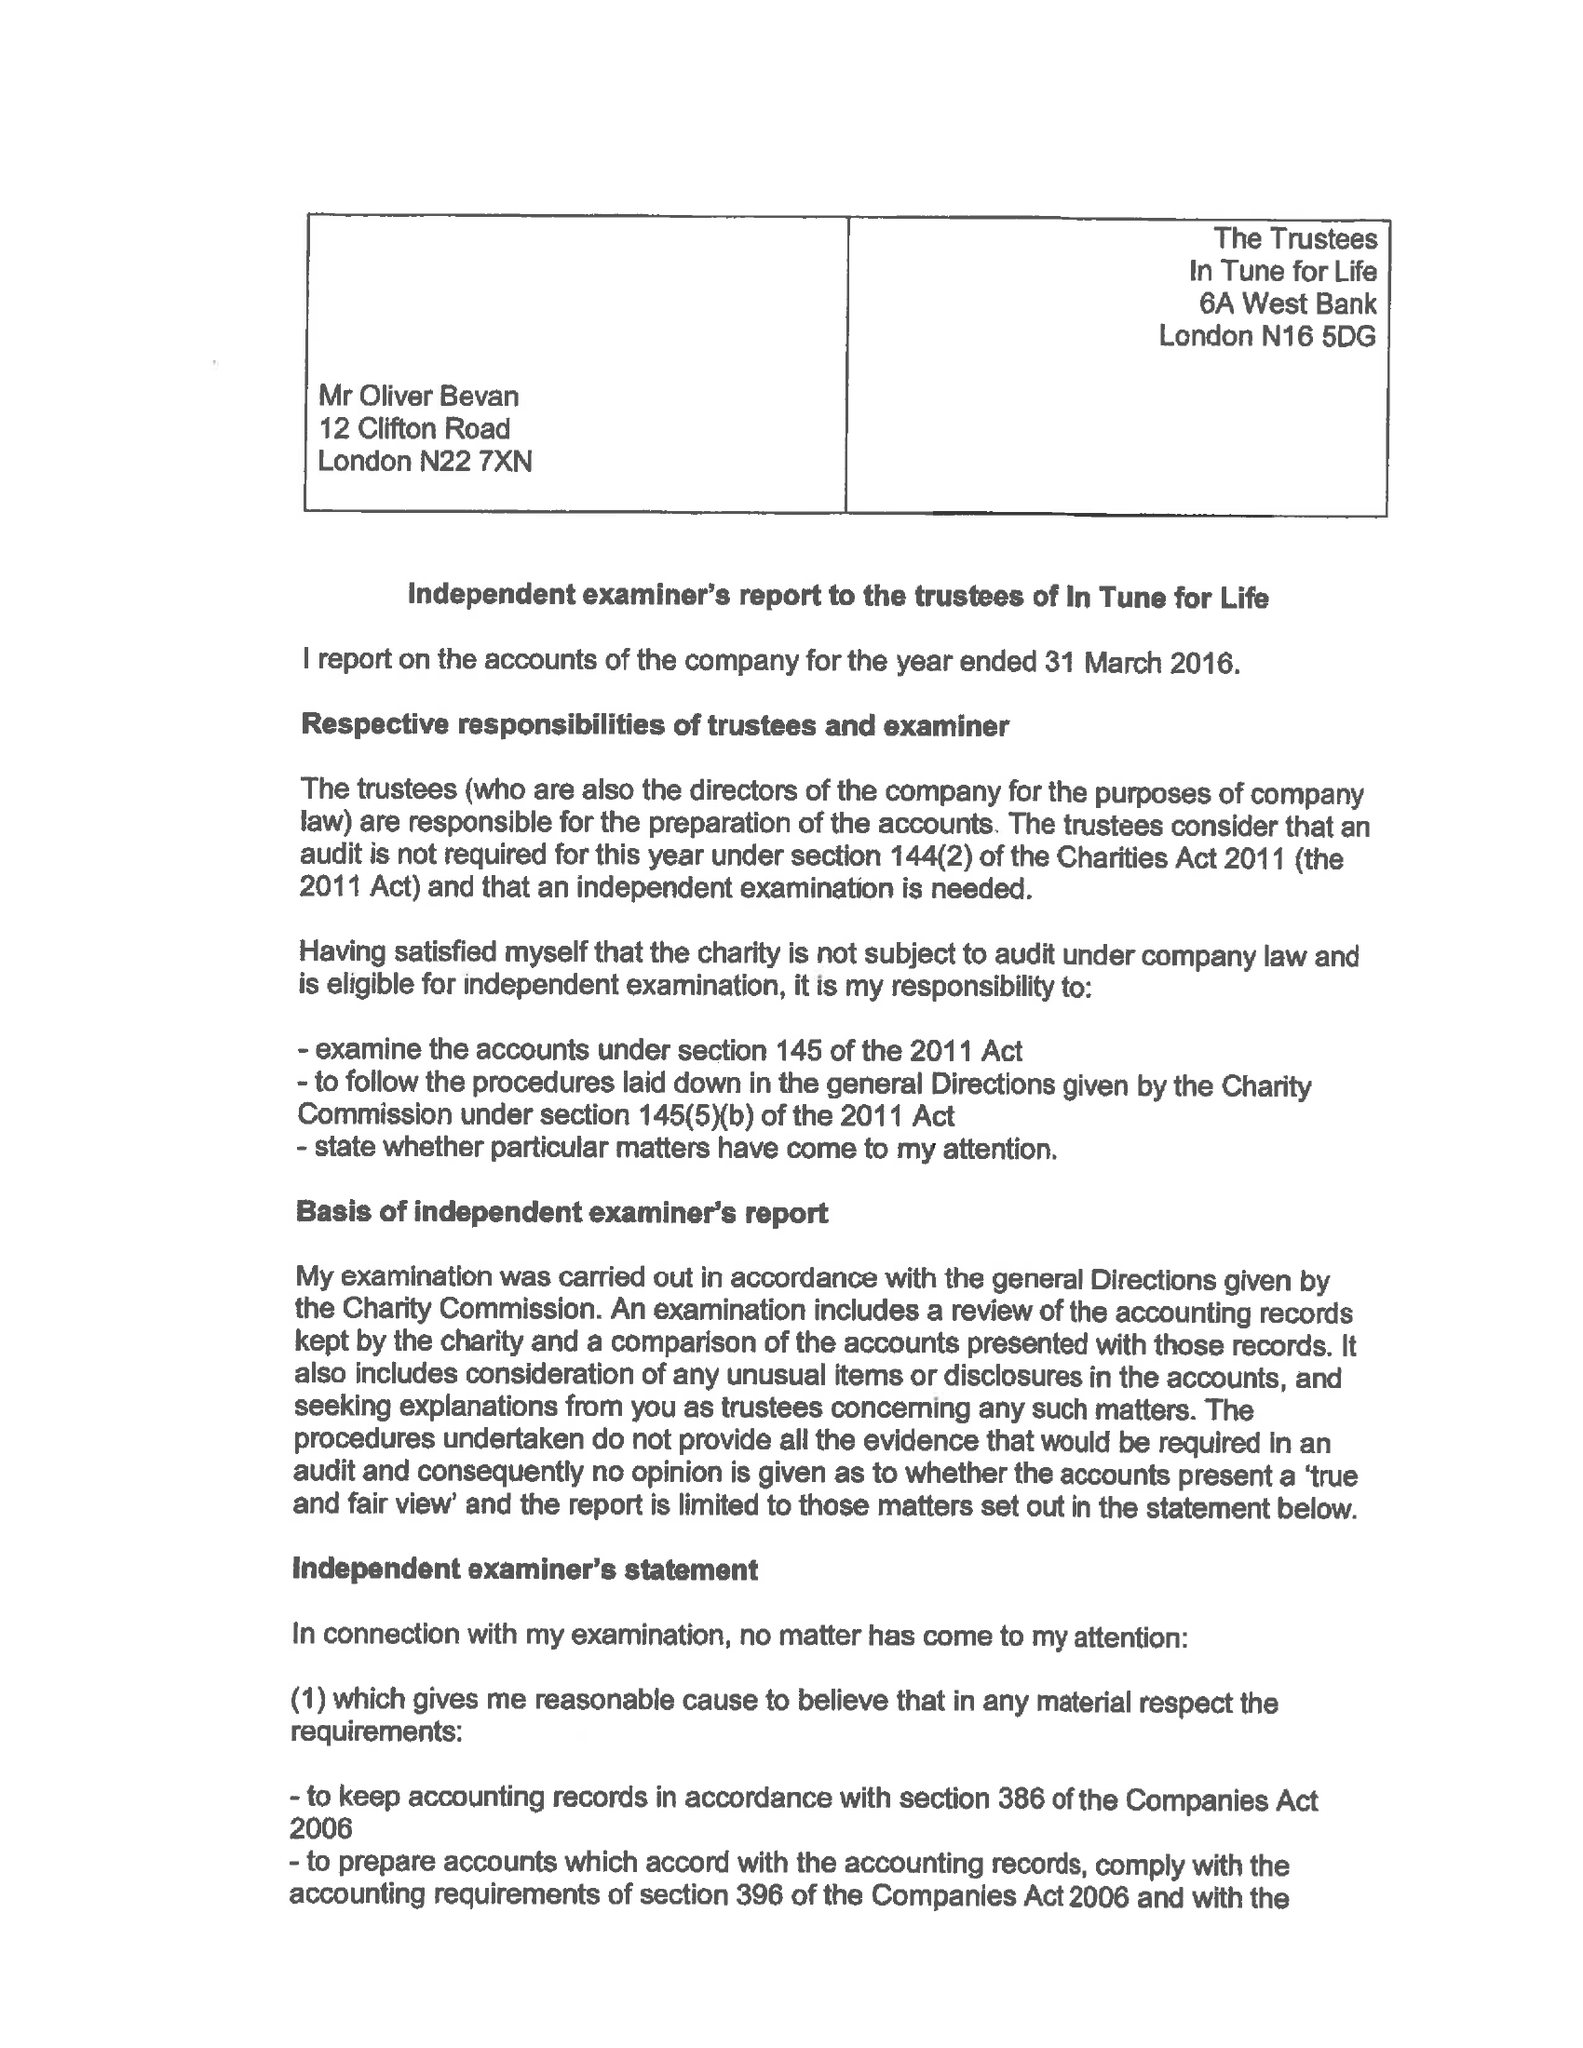What is the value for the spending_annually_in_british_pounds?
Answer the question using a single word or phrase. 28358.00 